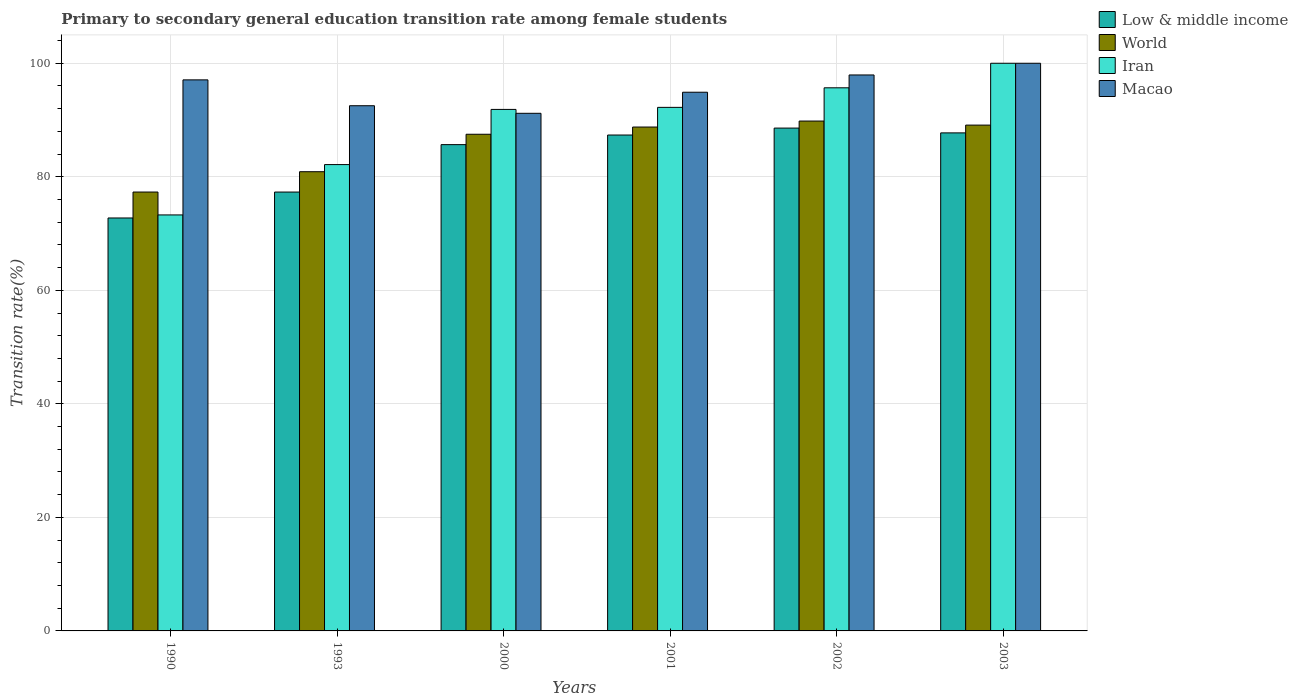How many different coloured bars are there?
Provide a succinct answer. 4. Are the number of bars on each tick of the X-axis equal?
Provide a succinct answer. Yes. What is the transition rate in Macao in 2002?
Provide a short and direct response. 97.94. Across all years, what is the minimum transition rate in Low & middle income?
Provide a succinct answer. 72.74. In which year was the transition rate in Macao maximum?
Give a very brief answer. 2003. What is the total transition rate in Low & middle income in the graph?
Provide a short and direct response. 499.4. What is the difference between the transition rate in World in 2001 and that in 2002?
Offer a terse response. -1.06. What is the difference between the transition rate in Low & middle income in 2001 and the transition rate in Iran in 1990?
Your response must be concise. 14.08. What is the average transition rate in Macao per year?
Provide a succinct answer. 95.6. In the year 1993, what is the difference between the transition rate in Low & middle income and transition rate in Iran?
Give a very brief answer. -4.84. In how many years, is the transition rate in Iran greater than 100 %?
Give a very brief answer. 0. What is the ratio of the transition rate in World in 1990 to that in 1993?
Give a very brief answer. 0.96. What is the difference between the highest and the second highest transition rate in Low & middle income?
Keep it short and to the point. 0.84. What is the difference between the highest and the lowest transition rate in Iran?
Keep it short and to the point. 26.72. In how many years, is the transition rate in World greater than the average transition rate in World taken over all years?
Ensure brevity in your answer.  4. Is the sum of the transition rate in Macao in 1993 and 2001 greater than the maximum transition rate in Low & middle income across all years?
Provide a short and direct response. Yes. What does the 2nd bar from the left in 2002 represents?
Your answer should be very brief. World. What does the 4th bar from the right in 1993 represents?
Keep it short and to the point. Low & middle income. Is it the case that in every year, the sum of the transition rate in Iran and transition rate in World is greater than the transition rate in Low & middle income?
Offer a very short reply. Yes. How many bars are there?
Offer a terse response. 24. Are all the bars in the graph horizontal?
Offer a very short reply. No. What is the difference between two consecutive major ticks on the Y-axis?
Provide a succinct answer. 20. Are the values on the major ticks of Y-axis written in scientific E-notation?
Ensure brevity in your answer.  No. Does the graph contain any zero values?
Provide a succinct answer. No. Does the graph contain grids?
Make the answer very short. Yes. How many legend labels are there?
Give a very brief answer. 4. How are the legend labels stacked?
Ensure brevity in your answer.  Vertical. What is the title of the graph?
Offer a very short reply. Primary to secondary general education transition rate among female students. What is the label or title of the X-axis?
Offer a terse response. Years. What is the label or title of the Y-axis?
Your answer should be compact. Transition rate(%). What is the Transition rate(%) in Low & middle income in 1990?
Provide a short and direct response. 72.74. What is the Transition rate(%) of World in 1990?
Make the answer very short. 77.31. What is the Transition rate(%) in Iran in 1990?
Provide a short and direct response. 73.28. What is the Transition rate(%) in Macao in 1990?
Provide a short and direct response. 97.07. What is the Transition rate(%) of Low & middle income in 1993?
Your response must be concise. 77.31. What is the Transition rate(%) of World in 1993?
Your response must be concise. 80.89. What is the Transition rate(%) in Iran in 1993?
Provide a succinct answer. 82.15. What is the Transition rate(%) in Macao in 1993?
Keep it short and to the point. 92.52. What is the Transition rate(%) of Low & middle income in 2000?
Your answer should be compact. 85.67. What is the Transition rate(%) of World in 2000?
Offer a terse response. 87.49. What is the Transition rate(%) in Iran in 2000?
Give a very brief answer. 91.87. What is the Transition rate(%) of Macao in 2000?
Your answer should be compact. 91.18. What is the Transition rate(%) in Low & middle income in 2001?
Provide a short and direct response. 87.36. What is the Transition rate(%) of World in 2001?
Keep it short and to the point. 88.76. What is the Transition rate(%) in Iran in 2001?
Provide a succinct answer. 92.23. What is the Transition rate(%) of Macao in 2001?
Make the answer very short. 94.9. What is the Transition rate(%) of Low & middle income in 2002?
Make the answer very short. 88.58. What is the Transition rate(%) of World in 2002?
Give a very brief answer. 89.82. What is the Transition rate(%) in Iran in 2002?
Make the answer very short. 95.68. What is the Transition rate(%) of Macao in 2002?
Your answer should be compact. 97.94. What is the Transition rate(%) of Low & middle income in 2003?
Provide a short and direct response. 87.74. What is the Transition rate(%) of World in 2003?
Offer a terse response. 89.11. What is the Transition rate(%) in Iran in 2003?
Offer a terse response. 100. Across all years, what is the maximum Transition rate(%) of Low & middle income?
Your answer should be compact. 88.58. Across all years, what is the maximum Transition rate(%) of World?
Offer a terse response. 89.82. Across all years, what is the maximum Transition rate(%) in Macao?
Offer a very short reply. 100. Across all years, what is the minimum Transition rate(%) of Low & middle income?
Offer a very short reply. 72.74. Across all years, what is the minimum Transition rate(%) of World?
Make the answer very short. 77.31. Across all years, what is the minimum Transition rate(%) of Iran?
Offer a very short reply. 73.28. Across all years, what is the minimum Transition rate(%) in Macao?
Your answer should be compact. 91.18. What is the total Transition rate(%) of Low & middle income in the graph?
Ensure brevity in your answer.  499.4. What is the total Transition rate(%) in World in the graph?
Your response must be concise. 513.39. What is the total Transition rate(%) of Iran in the graph?
Provide a succinct answer. 535.21. What is the total Transition rate(%) in Macao in the graph?
Your response must be concise. 573.61. What is the difference between the Transition rate(%) in Low & middle income in 1990 and that in 1993?
Provide a succinct answer. -4.57. What is the difference between the Transition rate(%) of World in 1990 and that in 1993?
Make the answer very short. -3.58. What is the difference between the Transition rate(%) in Iran in 1990 and that in 1993?
Your response must be concise. -8.87. What is the difference between the Transition rate(%) in Macao in 1990 and that in 1993?
Keep it short and to the point. 4.56. What is the difference between the Transition rate(%) of Low & middle income in 1990 and that in 2000?
Your response must be concise. -12.92. What is the difference between the Transition rate(%) in World in 1990 and that in 2000?
Ensure brevity in your answer.  -10.18. What is the difference between the Transition rate(%) in Iran in 1990 and that in 2000?
Your answer should be compact. -18.59. What is the difference between the Transition rate(%) of Macao in 1990 and that in 2000?
Provide a succinct answer. 5.89. What is the difference between the Transition rate(%) in Low & middle income in 1990 and that in 2001?
Your response must be concise. -14.61. What is the difference between the Transition rate(%) in World in 1990 and that in 2001?
Give a very brief answer. -11.45. What is the difference between the Transition rate(%) of Iran in 1990 and that in 2001?
Your answer should be compact. -18.95. What is the difference between the Transition rate(%) of Macao in 1990 and that in 2001?
Offer a terse response. 2.18. What is the difference between the Transition rate(%) of Low & middle income in 1990 and that in 2002?
Your answer should be compact. -15.83. What is the difference between the Transition rate(%) in World in 1990 and that in 2002?
Provide a succinct answer. -12.5. What is the difference between the Transition rate(%) in Iran in 1990 and that in 2002?
Your answer should be very brief. -22.39. What is the difference between the Transition rate(%) of Macao in 1990 and that in 2002?
Make the answer very short. -0.87. What is the difference between the Transition rate(%) in Low & middle income in 1990 and that in 2003?
Give a very brief answer. -14.99. What is the difference between the Transition rate(%) in World in 1990 and that in 2003?
Provide a succinct answer. -11.79. What is the difference between the Transition rate(%) of Iran in 1990 and that in 2003?
Give a very brief answer. -26.72. What is the difference between the Transition rate(%) of Macao in 1990 and that in 2003?
Provide a succinct answer. -2.93. What is the difference between the Transition rate(%) in Low & middle income in 1993 and that in 2000?
Your response must be concise. -8.35. What is the difference between the Transition rate(%) in World in 1993 and that in 2000?
Offer a very short reply. -6.6. What is the difference between the Transition rate(%) of Iran in 1993 and that in 2000?
Offer a terse response. -9.72. What is the difference between the Transition rate(%) of Macao in 1993 and that in 2000?
Provide a short and direct response. 1.33. What is the difference between the Transition rate(%) in Low & middle income in 1993 and that in 2001?
Offer a terse response. -10.05. What is the difference between the Transition rate(%) in World in 1993 and that in 2001?
Give a very brief answer. -7.87. What is the difference between the Transition rate(%) in Iran in 1993 and that in 2001?
Offer a very short reply. -10.08. What is the difference between the Transition rate(%) in Macao in 1993 and that in 2001?
Your response must be concise. -2.38. What is the difference between the Transition rate(%) in Low & middle income in 1993 and that in 2002?
Provide a succinct answer. -11.27. What is the difference between the Transition rate(%) of World in 1993 and that in 2002?
Provide a short and direct response. -8.92. What is the difference between the Transition rate(%) in Iran in 1993 and that in 2002?
Ensure brevity in your answer.  -13.52. What is the difference between the Transition rate(%) of Macao in 1993 and that in 2002?
Your answer should be very brief. -5.42. What is the difference between the Transition rate(%) in Low & middle income in 1993 and that in 2003?
Offer a terse response. -10.42. What is the difference between the Transition rate(%) of World in 1993 and that in 2003?
Offer a terse response. -8.21. What is the difference between the Transition rate(%) in Iran in 1993 and that in 2003?
Your answer should be compact. -17.85. What is the difference between the Transition rate(%) in Macao in 1993 and that in 2003?
Provide a short and direct response. -7.48. What is the difference between the Transition rate(%) in Low & middle income in 2000 and that in 2001?
Ensure brevity in your answer.  -1.69. What is the difference between the Transition rate(%) in World in 2000 and that in 2001?
Offer a terse response. -1.27. What is the difference between the Transition rate(%) in Iran in 2000 and that in 2001?
Offer a very short reply. -0.36. What is the difference between the Transition rate(%) of Macao in 2000 and that in 2001?
Ensure brevity in your answer.  -3.71. What is the difference between the Transition rate(%) in Low & middle income in 2000 and that in 2002?
Make the answer very short. -2.91. What is the difference between the Transition rate(%) of World in 2000 and that in 2002?
Ensure brevity in your answer.  -2.33. What is the difference between the Transition rate(%) in Iran in 2000 and that in 2002?
Provide a succinct answer. -3.81. What is the difference between the Transition rate(%) in Macao in 2000 and that in 2002?
Your answer should be compact. -6.76. What is the difference between the Transition rate(%) of Low & middle income in 2000 and that in 2003?
Keep it short and to the point. -2.07. What is the difference between the Transition rate(%) of World in 2000 and that in 2003?
Make the answer very short. -1.61. What is the difference between the Transition rate(%) of Iran in 2000 and that in 2003?
Offer a very short reply. -8.13. What is the difference between the Transition rate(%) in Macao in 2000 and that in 2003?
Your response must be concise. -8.82. What is the difference between the Transition rate(%) in Low & middle income in 2001 and that in 2002?
Offer a very short reply. -1.22. What is the difference between the Transition rate(%) in World in 2001 and that in 2002?
Offer a terse response. -1.06. What is the difference between the Transition rate(%) of Iran in 2001 and that in 2002?
Keep it short and to the point. -3.45. What is the difference between the Transition rate(%) of Macao in 2001 and that in 2002?
Make the answer very short. -3.04. What is the difference between the Transition rate(%) in Low & middle income in 2001 and that in 2003?
Offer a very short reply. -0.38. What is the difference between the Transition rate(%) of World in 2001 and that in 2003?
Make the answer very short. -0.34. What is the difference between the Transition rate(%) of Iran in 2001 and that in 2003?
Provide a short and direct response. -7.77. What is the difference between the Transition rate(%) in Macao in 2001 and that in 2003?
Ensure brevity in your answer.  -5.1. What is the difference between the Transition rate(%) of Low & middle income in 2002 and that in 2003?
Your response must be concise. 0.84. What is the difference between the Transition rate(%) in World in 2002 and that in 2003?
Give a very brief answer. 0.71. What is the difference between the Transition rate(%) of Iran in 2002 and that in 2003?
Offer a terse response. -4.32. What is the difference between the Transition rate(%) of Macao in 2002 and that in 2003?
Offer a terse response. -2.06. What is the difference between the Transition rate(%) in Low & middle income in 1990 and the Transition rate(%) in World in 1993?
Your answer should be very brief. -8.15. What is the difference between the Transition rate(%) of Low & middle income in 1990 and the Transition rate(%) of Iran in 1993?
Provide a succinct answer. -9.41. What is the difference between the Transition rate(%) of Low & middle income in 1990 and the Transition rate(%) of Macao in 1993?
Keep it short and to the point. -19.77. What is the difference between the Transition rate(%) of World in 1990 and the Transition rate(%) of Iran in 1993?
Give a very brief answer. -4.84. What is the difference between the Transition rate(%) in World in 1990 and the Transition rate(%) in Macao in 1993?
Your response must be concise. -15.2. What is the difference between the Transition rate(%) in Iran in 1990 and the Transition rate(%) in Macao in 1993?
Provide a short and direct response. -19.24. What is the difference between the Transition rate(%) in Low & middle income in 1990 and the Transition rate(%) in World in 2000?
Offer a very short reply. -14.75. What is the difference between the Transition rate(%) of Low & middle income in 1990 and the Transition rate(%) of Iran in 2000?
Offer a very short reply. -19.12. What is the difference between the Transition rate(%) in Low & middle income in 1990 and the Transition rate(%) in Macao in 2000?
Ensure brevity in your answer.  -18.44. What is the difference between the Transition rate(%) of World in 1990 and the Transition rate(%) of Iran in 2000?
Your answer should be compact. -14.55. What is the difference between the Transition rate(%) in World in 1990 and the Transition rate(%) in Macao in 2000?
Make the answer very short. -13.87. What is the difference between the Transition rate(%) in Iran in 1990 and the Transition rate(%) in Macao in 2000?
Offer a terse response. -17.9. What is the difference between the Transition rate(%) of Low & middle income in 1990 and the Transition rate(%) of World in 2001?
Keep it short and to the point. -16.02. What is the difference between the Transition rate(%) of Low & middle income in 1990 and the Transition rate(%) of Iran in 2001?
Offer a terse response. -19.48. What is the difference between the Transition rate(%) in Low & middle income in 1990 and the Transition rate(%) in Macao in 2001?
Give a very brief answer. -22.15. What is the difference between the Transition rate(%) in World in 1990 and the Transition rate(%) in Iran in 2001?
Your answer should be very brief. -14.91. What is the difference between the Transition rate(%) of World in 1990 and the Transition rate(%) of Macao in 2001?
Your answer should be compact. -17.58. What is the difference between the Transition rate(%) in Iran in 1990 and the Transition rate(%) in Macao in 2001?
Your answer should be compact. -21.61. What is the difference between the Transition rate(%) in Low & middle income in 1990 and the Transition rate(%) in World in 2002?
Offer a terse response. -17.07. What is the difference between the Transition rate(%) in Low & middle income in 1990 and the Transition rate(%) in Iran in 2002?
Make the answer very short. -22.93. What is the difference between the Transition rate(%) in Low & middle income in 1990 and the Transition rate(%) in Macao in 2002?
Your answer should be compact. -25.19. What is the difference between the Transition rate(%) in World in 1990 and the Transition rate(%) in Iran in 2002?
Provide a short and direct response. -18.36. What is the difference between the Transition rate(%) of World in 1990 and the Transition rate(%) of Macao in 2002?
Offer a terse response. -20.62. What is the difference between the Transition rate(%) of Iran in 1990 and the Transition rate(%) of Macao in 2002?
Ensure brevity in your answer.  -24.66. What is the difference between the Transition rate(%) in Low & middle income in 1990 and the Transition rate(%) in World in 2003?
Ensure brevity in your answer.  -16.36. What is the difference between the Transition rate(%) of Low & middle income in 1990 and the Transition rate(%) of Iran in 2003?
Ensure brevity in your answer.  -27.26. What is the difference between the Transition rate(%) of Low & middle income in 1990 and the Transition rate(%) of Macao in 2003?
Offer a very short reply. -27.26. What is the difference between the Transition rate(%) of World in 1990 and the Transition rate(%) of Iran in 2003?
Your answer should be very brief. -22.69. What is the difference between the Transition rate(%) in World in 1990 and the Transition rate(%) in Macao in 2003?
Make the answer very short. -22.69. What is the difference between the Transition rate(%) in Iran in 1990 and the Transition rate(%) in Macao in 2003?
Your response must be concise. -26.72. What is the difference between the Transition rate(%) in Low & middle income in 1993 and the Transition rate(%) in World in 2000?
Your response must be concise. -10.18. What is the difference between the Transition rate(%) in Low & middle income in 1993 and the Transition rate(%) in Iran in 2000?
Ensure brevity in your answer.  -14.56. What is the difference between the Transition rate(%) in Low & middle income in 1993 and the Transition rate(%) in Macao in 2000?
Make the answer very short. -13.87. What is the difference between the Transition rate(%) in World in 1993 and the Transition rate(%) in Iran in 2000?
Your answer should be compact. -10.97. What is the difference between the Transition rate(%) in World in 1993 and the Transition rate(%) in Macao in 2000?
Provide a succinct answer. -10.29. What is the difference between the Transition rate(%) in Iran in 1993 and the Transition rate(%) in Macao in 2000?
Your answer should be very brief. -9.03. What is the difference between the Transition rate(%) in Low & middle income in 1993 and the Transition rate(%) in World in 2001?
Provide a short and direct response. -11.45. What is the difference between the Transition rate(%) of Low & middle income in 1993 and the Transition rate(%) of Iran in 2001?
Offer a very short reply. -14.92. What is the difference between the Transition rate(%) in Low & middle income in 1993 and the Transition rate(%) in Macao in 2001?
Provide a succinct answer. -17.58. What is the difference between the Transition rate(%) of World in 1993 and the Transition rate(%) of Iran in 2001?
Offer a very short reply. -11.33. What is the difference between the Transition rate(%) in World in 1993 and the Transition rate(%) in Macao in 2001?
Your response must be concise. -14. What is the difference between the Transition rate(%) of Iran in 1993 and the Transition rate(%) of Macao in 2001?
Keep it short and to the point. -12.75. What is the difference between the Transition rate(%) in Low & middle income in 1993 and the Transition rate(%) in World in 2002?
Your answer should be very brief. -12.51. What is the difference between the Transition rate(%) of Low & middle income in 1993 and the Transition rate(%) of Iran in 2002?
Provide a short and direct response. -18.36. What is the difference between the Transition rate(%) in Low & middle income in 1993 and the Transition rate(%) in Macao in 2002?
Make the answer very short. -20.63. What is the difference between the Transition rate(%) of World in 1993 and the Transition rate(%) of Iran in 2002?
Offer a very short reply. -14.78. What is the difference between the Transition rate(%) of World in 1993 and the Transition rate(%) of Macao in 2002?
Keep it short and to the point. -17.04. What is the difference between the Transition rate(%) of Iran in 1993 and the Transition rate(%) of Macao in 2002?
Ensure brevity in your answer.  -15.79. What is the difference between the Transition rate(%) of Low & middle income in 1993 and the Transition rate(%) of World in 2003?
Your response must be concise. -11.79. What is the difference between the Transition rate(%) of Low & middle income in 1993 and the Transition rate(%) of Iran in 2003?
Offer a very short reply. -22.69. What is the difference between the Transition rate(%) of Low & middle income in 1993 and the Transition rate(%) of Macao in 2003?
Offer a very short reply. -22.69. What is the difference between the Transition rate(%) of World in 1993 and the Transition rate(%) of Iran in 2003?
Keep it short and to the point. -19.11. What is the difference between the Transition rate(%) in World in 1993 and the Transition rate(%) in Macao in 2003?
Keep it short and to the point. -19.11. What is the difference between the Transition rate(%) of Iran in 1993 and the Transition rate(%) of Macao in 2003?
Offer a terse response. -17.85. What is the difference between the Transition rate(%) in Low & middle income in 2000 and the Transition rate(%) in World in 2001?
Offer a very short reply. -3.1. What is the difference between the Transition rate(%) of Low & middle income in 2000 and the Transition rate(%) of Iran in 2001?
Provide a short and direct response. -6.56. What is the difference between the Transition rate(%) of Low & middle income in 2000 and the Transition rate(%) of Macao in 2001?
Make the answer very short. -9.23. What is the difference between the Transition rate(%) in World in 2000 and the Transition rate(%) in Iran in 2001?
Your response must be concise. -4.74. What is the difference between the Transition rate(%) of World in 2000 and the Transition rate(%) of Macao in 2001?
Provide a succinct answer. -7.4. What is the difference between the Transition rate(%) in Iran in 2000 and the Transition rate(%) in Macao in 2001?
Provide a short and direct response. -3.03. What is the difference between the Transition rate(%) of Low & middle income in 2000 and the Transition rate(%) of World in 2002?
Provide a succinct answer. -4.15. What is the difference between the Transition rate(%) in Low & middle income in 2000 and the Transition rate(%) in Iran in 2002?
Offer a terse response. -10.01. What is the difference between the Transition rate(%) in Low & middle income in 2000 and the Transition rate(%) in Macao in 2002?
Ensure brevity in your answer.  -12.27. What is the difference between the Transition rate(%) of World in 2000 and the Transition rate(%) of Iran in 2002?
Keep it short and to the point. -8.18. What is the difference between the Transition rate(%) in World in 2000 and the Transition rate(%) in Macao in 2002?
Ensure brevity in your answer.  -10.45. What is the difference between the Transition rate(%) in Iran in 2000 and the Transition rate(%) in Macao in 2002?
Ensure brevity in your answer.  -6.07. What is the difference between the Transition rate(%) of Low & middle income in 2000 and the Transition rate(%) of World in 2003?
Make the answer very short. -3.44. What is the difference between the Transition rate(%) in Low & middle income in 2000 and the Transition rate(%) in Iran in 2003?
Give a very brief answer. -14.33. What is the difference between the Transition rate(%) in Low & middle income in 2000 and the Transition rate(%) in Macao in 2003?
Ensure brevity in your answer.  -14.33. What is the difference between the Transition rate(%) of World in 2000 and the Transition rate(%) of Iran in 2003?
Your answer should be very brief. -12.51. What is the difference between the Transition rate(%) in World in 2000 and the Transition rate(%) in Macao in 2003?
Give a very brief answer. -12.51. What is the difference between the Transition rate(%) in Iran in 2000 and the Transition rate(%) in Macao in 2003?
Your response must be concise. -8.13. What is the difference between the Transition rate(%) in Low & middle income in 2001 and the Transition rate(%) in World in 2002?
Make the answer very short. -2.46. What is the difference between the Transition rate(%) in Low & middle income in 2001 and the Transition rate(%) in Iran in 2002?
Ensure brevity in your answer.  -8.32. What is the difference between the Transition rate(%) in Low & middle income in 2001 and the Transition rate(%) in Macao in 2002?
Offer a terse response. -10.58. What is the difference between the Transition rate(%) of World in 2001 and the Transition rate(%) of Iran in 2002?
Your answer should be very brief. -6.91. What is the difference between the Transition rate(%) in World in 2001 and the Transition rate(%) in Macao in 2002?
Offer a terse response. -9.18. What is the difference between the Transition rate(%) in Iran in 2001 and the Transition rate(%) in Macao in 2002?
Provide a succinct answer. -5.71. What is the difference between the Transition rate(%) in Low & middle income in 2001 and the Transition rate(%) in World in 2003?
Give a very brief answer. -1.75. What is the difference between the Transition rate(%) in Low & middle income in 2001 and the Transition rate(%) in Iran in 2003?
Your response must be concise. -12.64. What is the difference between the Transition rate(%) of Low & middle income in 2001 and the Transition rate(%) of Macao in 2003?
Your response must be concise. -12.64. What is the difference between the Transition rate(%) of World in 2001 and the Transition rate(%) of Iran in 2003?
Provide a succinct answer. -11.24. What is the difference between the Transition rate(%) of World in 2001 and the Transition rate(%) of Macao in 2003?
Your answer should be very brief. -11.24. What is the difference between the Transition rate(%) of Iran in 2001 and the Transition rate(%) of Macao in 2003?
Make the answer very short. -7.77. What is the difference between the Transition rate(%) of Low & middle income in 2002 and the Transition rate(%) of World in 2003?
Keep it short and to the point. -0.53. What is the difference between the Transition rate(%) of Low & middle income in 2002 and the Transition rate(%) of Iran in 2003?
Ensure brevity in your answer.  -11.42. What is the difference between the Transition rate(%) in Low & middle income in 2002 and the Transition rate(%) in Macao in 2003?
Your answer should be compact. -11.42. What is the difference between the Transition rate(%) in World in 2002 and the Transition rate(%) in Iran in 2003?
Your answer should be compact. -10.18. What is the difference between the Transition rate(%) in World in 2002 and the Transition rate(%) in Macao in 2003?
Your answer should be very brief. -10.18. What is the difference between the Transition rate(%) in Iran in 2002 and the Transition rate(%) in Macao in 2003?
Provide a short and direct response. -4.32. What is the average Transition rate(%) in Low & middle income per year?
Make the answer very short. 83.23. What is the average Transition rate(%) of World per year?
Your answer should be very brief. 85.56. What is the average Transition rate(%) in Iran per year?
Your answer should be compact. 89.2. What is the average Transition rate(%) of Macao per year?
Give a very brief answer. 95.6. In the year 1990, what is the difference between the Transition rate(%) of Low & middle income and Transition rate(%) of World?
Provide a succinct answer. -4.57. In the year 1990, what is the difference between the Transition rate(%) in Low & middle income and Transition rate(%) in Iran?
Offer a terse response. -0.54. In the year 1990, what is the difference between the Transition rate(%) of Low & middle income and Transition rate(%) of Macao?
Provide a succinct answer. -24.33. In the year 1990, what is the difference between the Transition rate(%) in World and Transition rate(%) in Iran?
Provide a succinct answer. 4.03. In the year 1990, what is the difference between the Transition rate(%) of World and Transition rate(%) of Macao?
Give a very brief answer. -19.76. In the year 1990, what is the difference between the Transition rate(%) of Iran and Transition rate(%) of Macao?
Make the answer very short. -23.79. In the year 1993, what is the difference between the Transition rate(%) in Low & middle income and Transition rate(%) in World?
Make the answer very short. -3.58. In the year 1993, what is the difference between the Transition rate(%) of Low & middle income and Transition rate(%) of Iran?
Give a very brief answer. -4.84. In the year 1993, what is the difference between the Transition rate(%) in Low & middle income and Transition rate(%) in Macao?
Provide a succinct answer. -15.21. In the year 1993, what is the difference between the Transition rate(%) of World and Transition rate(%) of Iran?
Offer a terse response. -1.26. In the year 1993, what is the difference between the Transition rate(%) in World and Transition rate(%) in Macao?
Your response must be concise. -11.62. In the year 1993, what is the difference between the Transition rate(%) in Iran and Transition rate(%) in Macao?
Your answer should be compact. -10.37. In the year 2000, what is the difference between the Transition rate(%) of Low & middle income and Transition rate(%) of World?
Provide a succinct answer. -1.83. In the year 2000, what is the difference between the Transition rate(%) of Low & middle income and Transition rate(%) of Iran?
Offer a very short reply. -6.2. In the year 2000, what is the difference between the Transition rate(%) of Low & middle income and Transition rate(%) of Macao?
Provide a short and direct response. -5.52. In the year 2000, what is the difference between the Transition rate(%) in World and Transition rate(%) in Iran?
Offer a terse response. -4.38. In the year 2000, what is the difference between the Transition rate(%) in World and Transition rate(%) in Macao?
Your answer should be compact. -3.69. In the year 2000, what is the difference between the Transition rate(%) of Iran and Transition rate(%) of Macao?
Your answer should be very brief. 0.69. In the year 2001, what is the difference between the Transition rate(%) of Low & middle income and Transition rate(%) of World?
Make the answer very short. -1.41. In the year 2001, what is the difference between the Transition rate(%) of Low & middle income and Transition rate(%) of Iran?
Provide a short and direct response. -4.87. In the year 2001, what is the difference between the Transition rate(%) in Low & middle income and Transition rate(%) in Macao?
Ensure brevity in your answer.  -7.54. In the year 2001, what is the difference between the Transition rate(%) of World and Transition rate(%) of Iran?
Make the answer very short. -3.47. In the year 2001, what is the difference between the Transition rate(%) in World and Transition rate(%) in Macao?
Make the answer very short. -6.13. In the year 2001, what is the difference between the Transition rate(%) of Iran and Transition rate(%) of Macao?
Offer a very short reply. -2.67. In the year 2002, what is the difference between the Transition rate(%) of Low & middle income and Transition rate(%) of World?
Ensure brevity in your answer.  -1.24. In the year 2002, what is the difference between the Transition rate(%) of Low & middle income and Transition rate(%) of Iran?
Offer a terse response. -7.1. In the year 2002, what is the difference between the Transition rate(%) in Low & middle income and Transition rate(%) in Macao?
Provide a short and direct response. -9.36. In the year 2002, what is the difference between the Transition rate(%) of World and Transition rate(%) of Iran?
Offer a terse response. -5.86. In the year 2002, what is the difference between the Transition rate(%) of World and Transition rate(%) of Macao?
Provide a succinct answer. -8.12. In the year 2002, what is the difference between the Transition rate(%) in Iran and Transition rate(%) in Macao?
Your response must be concise. -2.26. In the year 2003, what is the difference between the Transition rate(%) of Low & middle income and Transition rate(%) of World?
Provide a short and direct response. -1.37. In the year 2003, what is the difference between the Transition rate(%) in Low & middle income and Transition rate(%) in Iran?
Make the answer very short. -12.26. In the year 2003, what is the difference between the Transition rate(%) of Low & middle income and Transition rate(%) of Macao?
Your answer should be compact. -12.26. In the year 2003, what is the difference between the Transition rate(%) in World and Transition rate(%) in Iran?
Your answer should be compact. -10.89. In the year 2003, what is the difference between the Transition rate(%) of World and Transition rate(%) of Macao?
Provide a short and direct response. -10.89. What is the ratio of the Transition rate(%) in Low & middle income in 1990 to that in 1993?
Provide a short and direct response. 0.94. What is the ratio of the Transition rate(%) of World in 1990 to that in 1993?
Your answer should be compact. 0.96. What is the ratio of the Transition rate(%) of Iran in 1990 to that in 1993?
Your answer should be very brief. 0.89. What is the ratio of the Transition rate(%) of Macao in 1990 to that in 1993?
Offer a terse response. 1.05. What is the ratio of the Transition rate(%) in Low & middle income in 1990 to that in 2000?
Offer a terse response. 0.85. What is the ratio of the Transition rate(%) in World in 1990 to that in 2000?
Your answer should be very brief. 0.88. What is the ratio of the Transition rate(%) in Iran in 1990 to that in 2000?
Offer a very short reply. 0.8. What is the ratio of the Transition rate(%) in Macao in 1990 to that in 2000?
Provide a succinct answer. 1.06. What is the ratio of the Transition rate(%) in Low & middle income in 1990 to that in 2001?
Your answer should be very brief. 0.83. What is the ratio of the Transition rate(%) in World in 1990 to that in 2001?
Offer a very short reply. 0.87. What is the ratio of the Transition rate(%) of Iran in 1990 to that in 2001?
Give a very brief answer. 0.79. What is the ratio of the Transition rate(%) of Macao in 1990 to that in 2001?
Your response must be concise. 1.02. What is the ratio of the Transition rate(%) in Low & middle income in 1990 to that in 2002?
Offer a very short reply. 0.82. What is the ratio of the Transition rate(%) of World in 1990 to that in 2002?
Provide a short and direct response. 0.86. What is the ratio of the Transition rate(%) of Iran in 1990 to that in 2002?
Your answer should be compact. 0.77. What is the ratio of the Transition rate(%) in Low & middle income in 1990 to that in 2003?
Keep it short and to the point. 0.83. What is the ratio of the Transition rate(%) in World in 1990 to that in 2003?
Your response must be concise. 0.87. What is the ratio of the Transition rate(%) of Iran in 1990 to that in 2003?
Your answer should be very brief. 0.73. What is the ratio of the Transition rate(%) in Macao in 1990 to that in 2003?
Your answer should be very brief. 0.97. What is the ratio of the Transition rate(%) of Low & middle income in 1993 to that in 2000?
Provide a succinct answer. 0.9. What is the ratio of the Transition rate(%) of World in 1993 to that in 2000?
Offer a terse response. 0.92. What is the ratio of the Transition rate(%) of Iran in 1993 to that in 2000?
Keep it short and to the point. 0.89. What is the ratio of the Transition rate(%) of Macao in 1993 to that in 2000?
Provide a short and direct response. 1.01. What is the ratio of the Transition rate(%) in Low & middle income in 1993 to that in 2001?
Offer a terse response. 0.89. What is the ratio of the Transition rate(%) in World in 1993 to that in 2001?
Your response must be concise. 0.91. What is the ratio of the Transition rate(%) of Iran in 1993 to that in 2001?
Ensure brevity in your answer.  0.89. What is the ratio of the Transition rate(%) of Macao in 1993 to that in 2001?
Keep it short and to the point. 0.97. What is the ratio of the Transition rate(%) in Low & middle income in 1993 to that in 2002?
Make the answer very short. 0.87. What is the ratio of the Transition rate(%) of World in 1993 to that in 2002?
Offer a terse response. 0.9. What is the ratio of the Transition rate(%) in Iran in 1993 to that in 2002?
Give a very brief answer. 0.86. What is the ratio of the Transition rate(%) in Macao in 1993 to that in 2002?
Offer a very short reply. 0.94. What is the ratio of the Transition rate(%) of Low & middle income in 1993 to that in 2003?
Your answer should be very brief. 0.88. What is the ratio of the Transition rate(%) in World in 1993 to that in 2003?
Ensure brevity in your answer.  0.91. What is the ratio of the Transition rate(%) of Iran in 1993 to that in 2003?
Offer a very short reply. 0.82. What is the ratio of the Transition rate(%) in Macao in 1993 to that in 2003?
Offer a very short reply. 0.93. What is the ratio of the Transition rate(%) of Low & middle income in 2000 to that in 2001?
Offer a terse response. 0.98. What is the ratio of the Transition rate(%) in World in 2000 to that in 2001?
Make the answer very short. 0.99. What is the ratio of the Transition rate(%) of Iran in 2000 to that in 2001?
Your answer should be very brief. 1. What is the ratio of the Transition rate(%) in Macao in 2000 to that in 2001?
Offer a terse response. 0.96. What is the ratio of the Transition rate(%) in Low & middle income in 2000 to that in 2002?
Offer a terse response. 0.97. What is the ratio of the Transition rate(%) in World in 2000 to that in 2002?
Offer a very short reply. 0.97. What is the ratio of the Transition rate(%) of Iran in 2000 to that in 2002?
Your answer should be very brief. 0.96. What is the ratio of the Transition rate(%) in Low & middle income in 2000 to that in 2003?
Keep it short and to the point. 0.98. What is the ratio of the Transition rate(%) in World in 2000 to that in 2003?
Provide a succinct answer. 0.98. What is the ratio of the Transition rate(%) of Iran in 2000 to that in 2003?
Provide a succinct answer. 0.92. What is the ratio of the Transition rate(%) in Macao in 2000 to that in 2003?
Keep it short and to the point. 0.91. What is the ratio of the Transition rate(%) of Low & middle income in 2001 to that in 2002?
Make the answer very short. 0.99. What is the ratio of the Transition rate(%) of World in 2001 to that in 2002?
Your answer should be compact. 0.99. What is the ratio of the Transition rate(%) in Macao in 2001 to that in 2002?
Make the answer very short. 0.97. What is the ratio of the Transition rate(%) in Low & middle income in 2001 to that in 2003?
Offer a terse response. 1. What is the ratio of the Transition rate(%) of World in 2001 to that in 2003?
Your answer should be compact. 1. What is the ratio of the Transition rate(%) of Iran in 2001 to that in 2003?
Provide a succinct answer. 0.92. What is the ratio of the Transition rate(%) in Macao in 2001 to that in 2003?
Ensure brevity in your answer.  0.95. What is the ratio of the Transition rate(%) in Low & middle income in 2002 to that in 2003?
Your answer should be compact. 1.01. What is the ratio of the Transition rate(%) of Iran in 2002 to that in 2003?
Offer a very short reply. 0.96. What is the ratio of the Transition rate(%) in Macao in 2002 to that in 2003?
Ensure brevity in your answer.  0.98. What is the difference between the highest and the second highest Transition rate(%) in Low & middle income?
Offer a very short reply. 0.84. What is the difference between the highest and the second highest Transition rate(%) of World?
Provide a succinct answer. 0.71. What is the difference between the highest and the second highest Transition rate(%) of Iran?
Provide a short and direct response. 4.32. What is the difference between the highest and the second highest Transition rate(%) in Macao?
Your answer should be compact. 2.06. What is the difference between the highest and the lowest Transition rate(%) in Low & middle income?
Your response must be concise. 15.83. What is the difference between the highest and the lowest Transition rate(%) of World?
Offer a terse response. 12.5. What is the difference between the highest and the lowest Transition rate(%) of Iran?
Make the answer very short. 26.72. What is the difference between the highest and the lowest Transition rate(%) of Macao?
Provide a short and direct response. 8.82. 